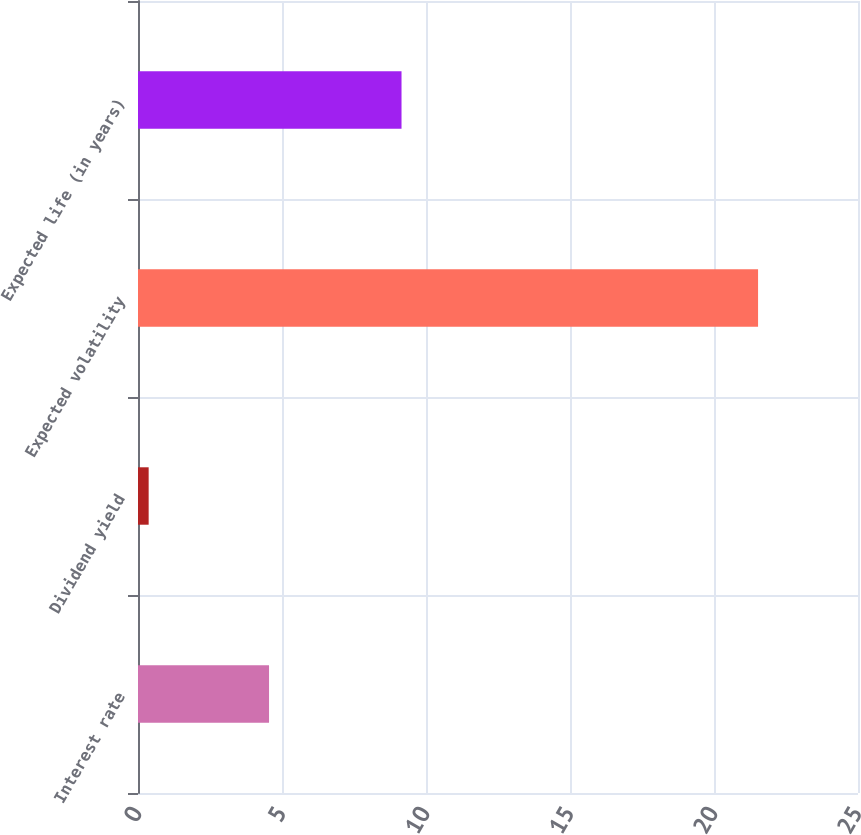<chart> <loc_0><loc_0><loc_500><loc_500><bar_chart><fcel>Interest rate<fcel>Dividend yield<fcel>Expected volatility<fcel>Expected life (in years)<nl><fcel>4.55<fcel>0.37<fcel>21.53<fcel>9.15<nl></chart> 